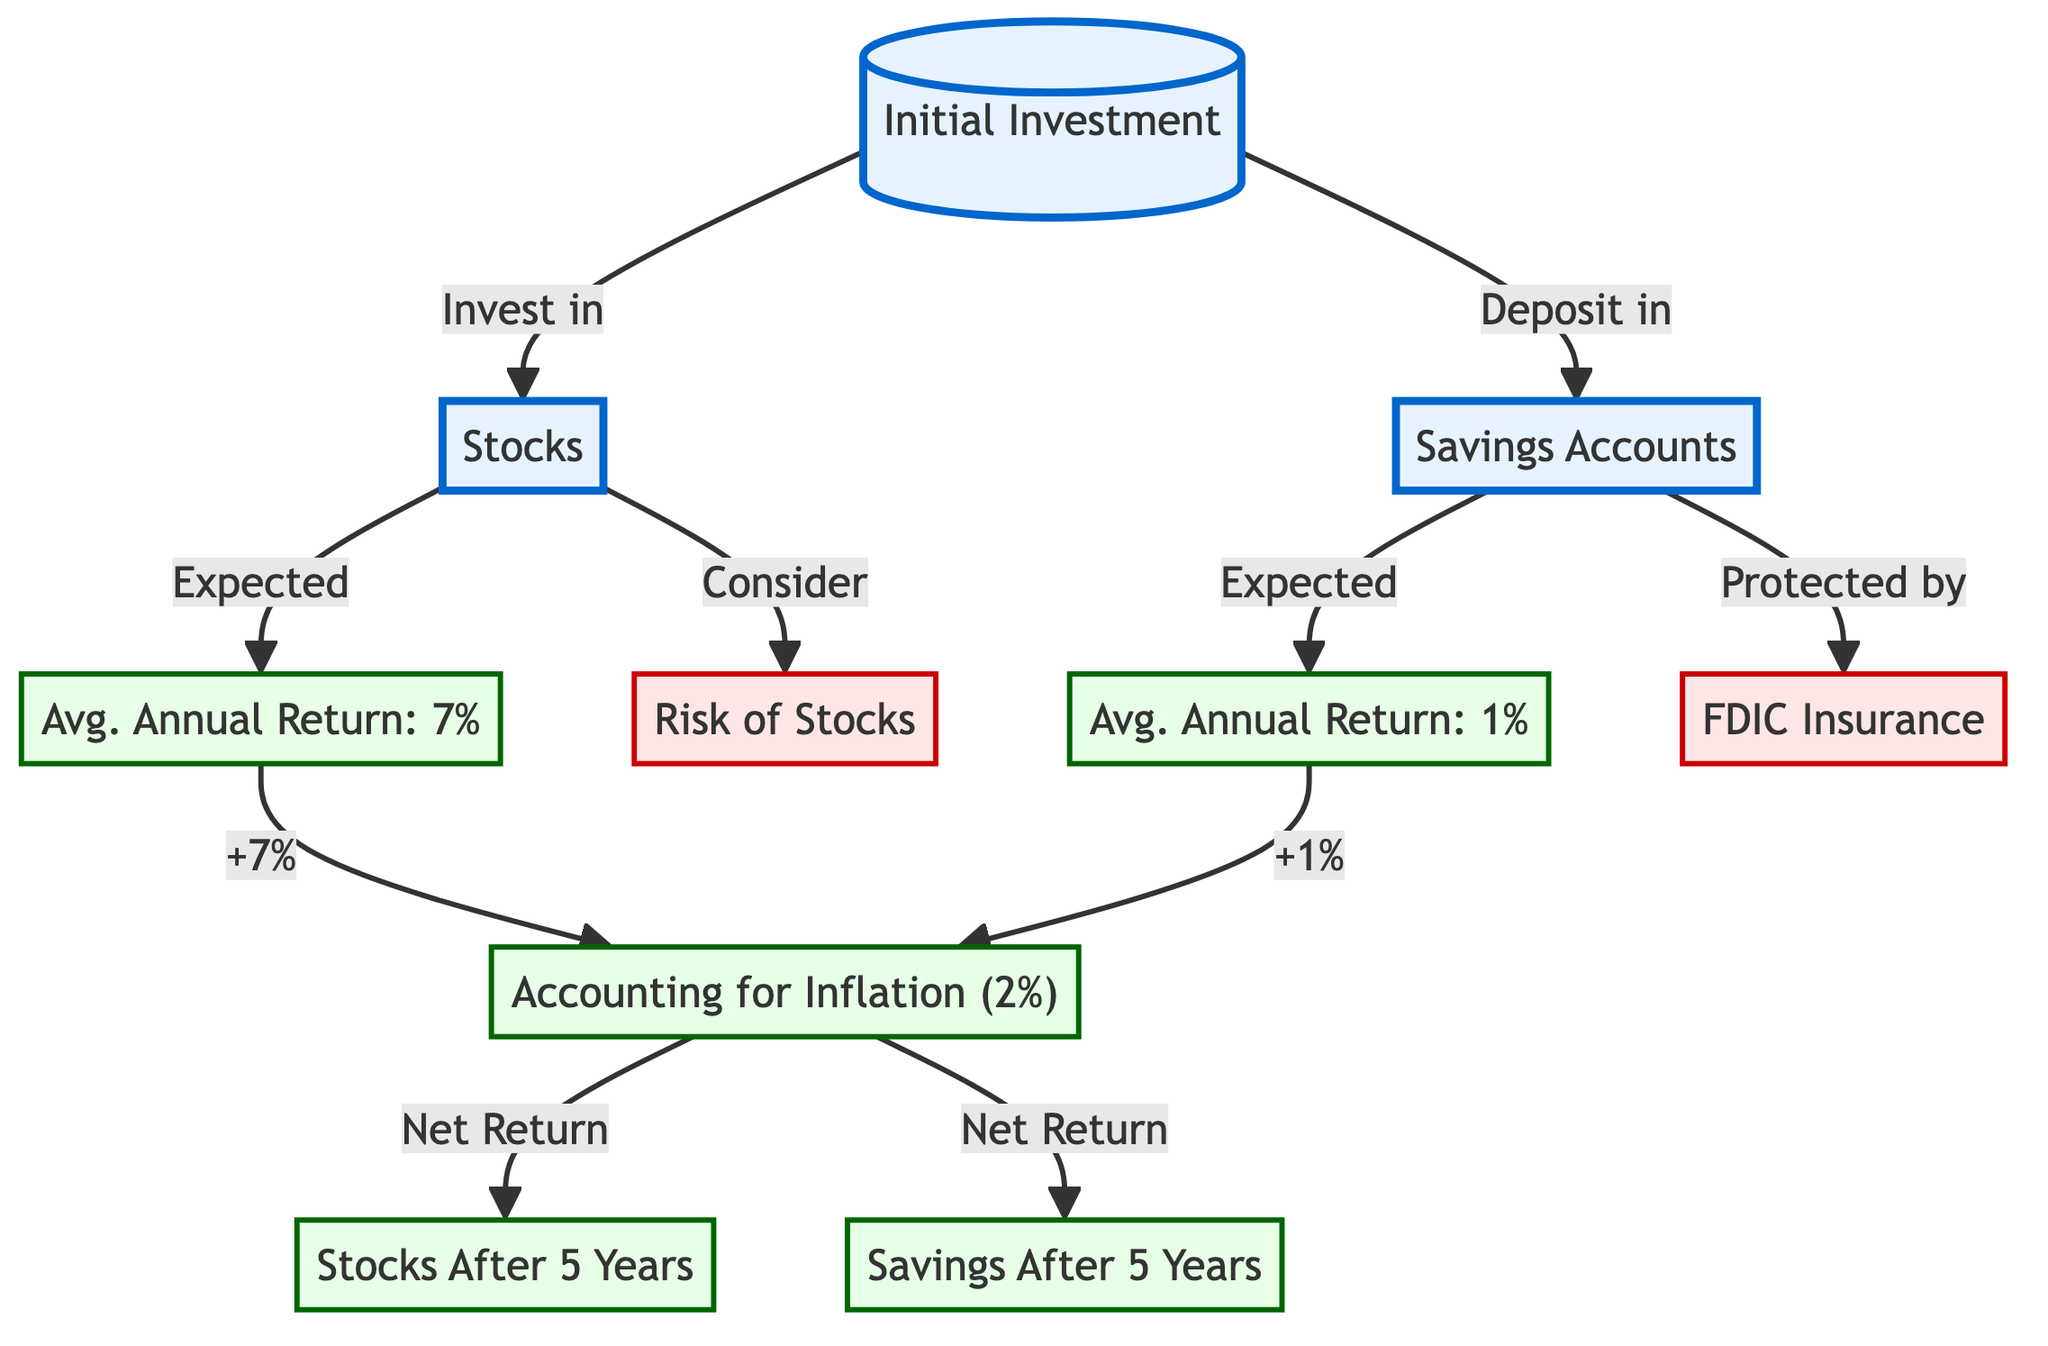What is the average annual return for Stocks? The diagram states the average annual return for Stocks is 7%. This information is directly presented in the node labeled "Avg. Annual Return: 7%."
Answer: 7% What protects Savings Accounts? The diagram indicates that Savings Accounts are "Protected by FDIC Insurance." This is explicitly stated in the node connected to the Savings Accounts node by an arrow.
Answer: FDIC Insurance What is the net return after accounting for inflation for Stocks? To find the net return for Stocks, we start with the average annual return of 7%, and then we account for inflation, which is 2%. This gives us a net return of 5% (7% - 2%). This is shown in the flow from "Avg. Annual Return: 7%" through "Accounting for Inflation (2%)."
Answer: 5% What is the final return for Savings Accounts after 5 years? The expected average annual return for Savings Accounts is 1%. After accounting for inflation of 2%, the net return becomes -1% (1% - 2%). This is reflected in the flow from "Avg. Annual Return: 1%" through "Accounting for Inflation (2%)."
Answer: -1% What risks are associated with Stocks? The diagram mentions a general "Risk of Stocks," indicated by the node that connects to the Stocks node. It highlights that Stocks come with risks that need to be considered.
Answer: Risk of Stocks How many main investment options are illustrated in the diagram? The diagram includes two main investment options: Stocks and Savings Accounts. These are the main nodes branching from the initial investment node. Therefore, there are two options displayed.
Answer: 2 What is the average annual return for Savings Accounts? The diagram explicitly lists the average annual return for Savings Accounts as 1% in the node labeled "Avg. Annual Return: 1%."
Answer: 1% What is the relationship between the return for Stocks and inflation? The diagram specifies that after accounting for inflation (2%), the net return for Stocks is derived by subtracting this rate from the average annual return of 7%. This calculation represents the relationship clearly as a deduction.
Answer: Subtraction What element depicts the concept of risk for Savings Accounts? The diagram illustrates that Savings Accounts are "Protected by FDIC Insurance," which serves as the risk mitigation feature for Savings Accounts. The presence of this node connects Savings Accounts to a protective measure against risks.
Answer: FDIC Insurance 